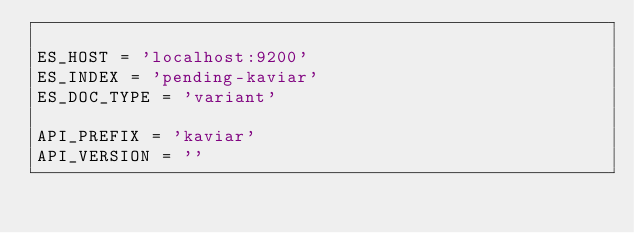Convert code to text. <code><loc_0><loc_0><loc_500><loc_500><_Python_>
ES_HOST = 'localhost:9200'
ES_INDEX = 'pending-kaviar'
ES_DOC_TYPE = 'variant'

API_PREFIX = 'kaviar'
API_VERSION = ''
</code> 